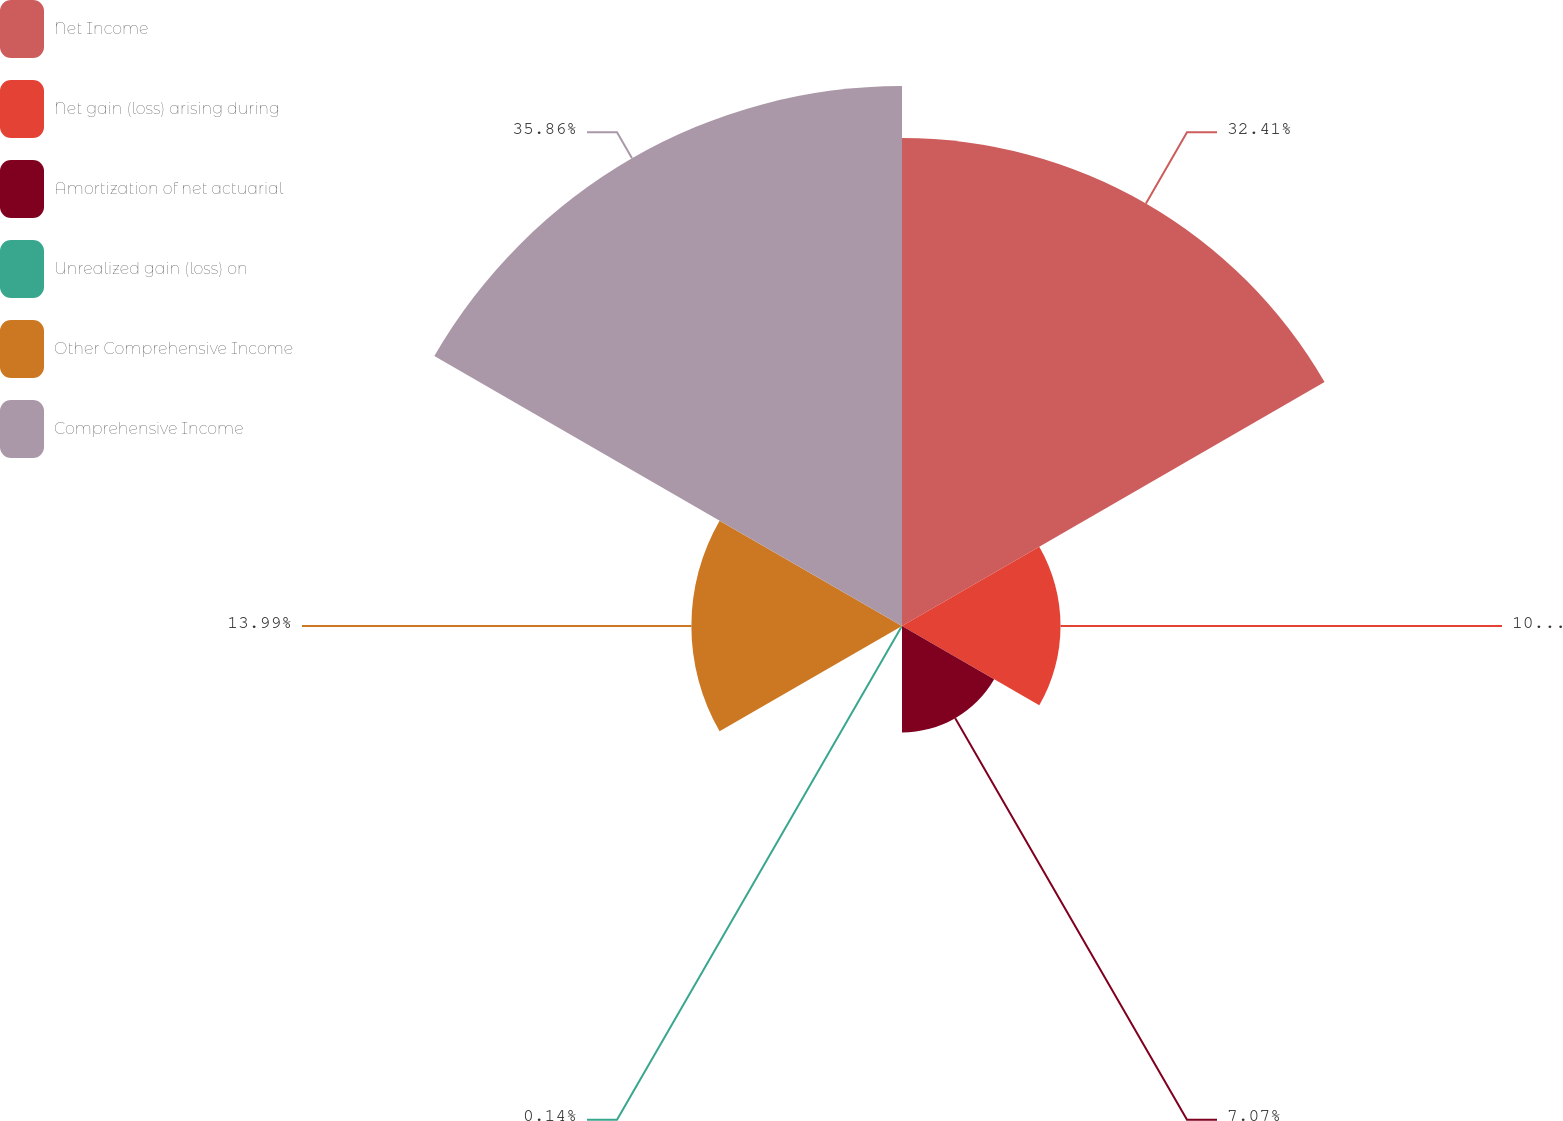Convert chart to OTSL. <chart><loc_0><loc_0><loc_500><loc_500><pie_chart><fcel>Net Income<fcel>Net gain (loss) arising during<fcel>Amortization of net actuarial<fcel>Unrealized gain (loss) on<fcel>Other Comprehensive Income<fcel>Comprehensive Income<nl><fcel>32.41%<fcel>10.53%<fcel>7.07%<fcel>0.14%<fcel>13.99%<fcel>35.87%<nl></chart> 